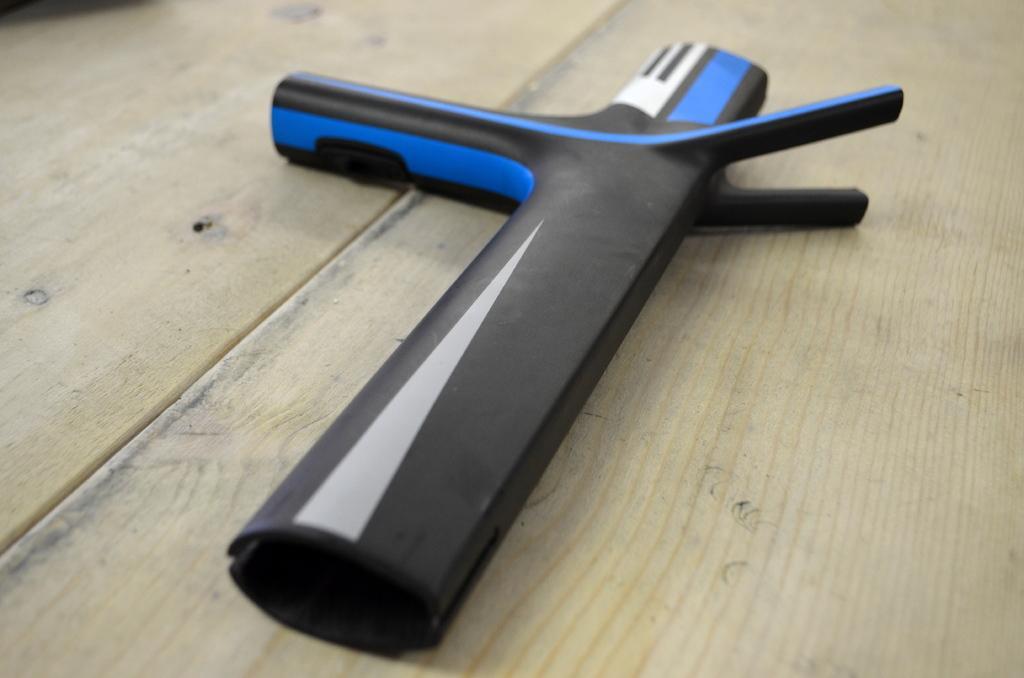Could you give a brief overview of what you see in this image? In the center of this picture we can see a black color object is placed on the top of the wooden object which seems to be the table. 